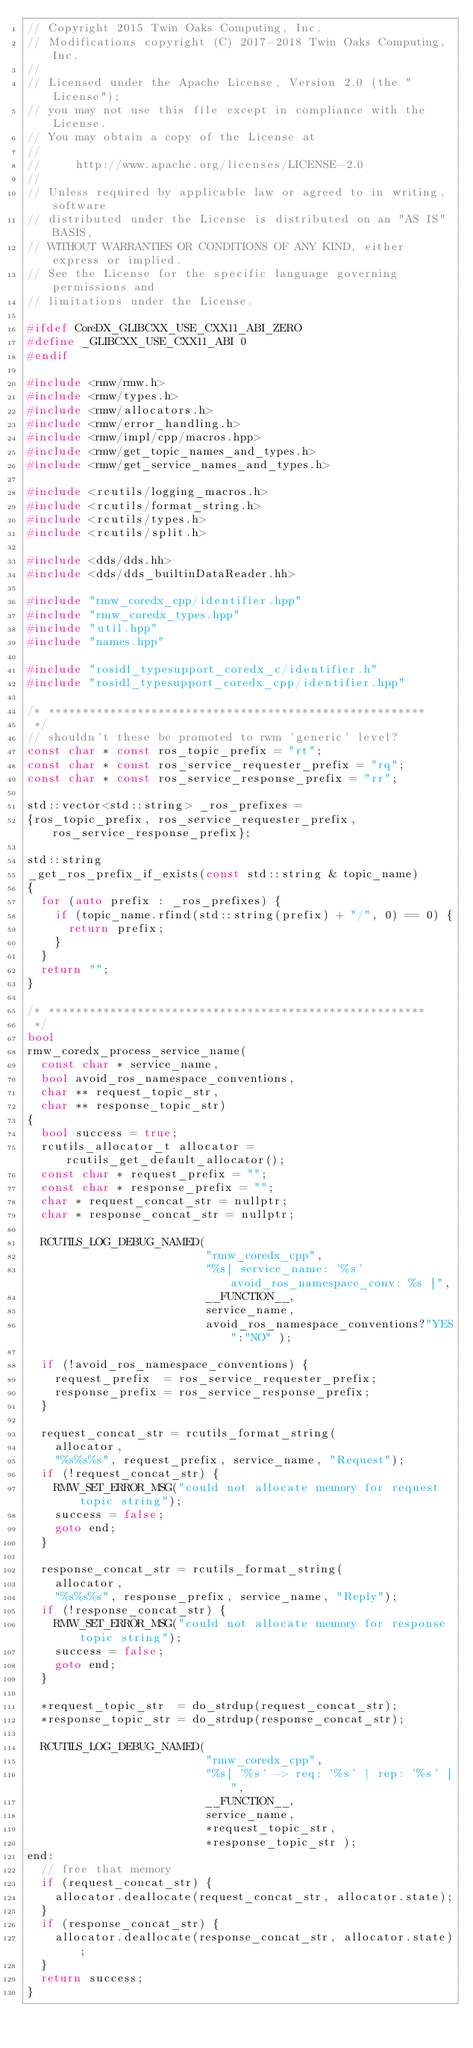<code> <loc_0><loc_0><loc_500><loc_500><_C++_>// Copyright 2015 Twin Oaks Computing, Inc.
// Modifications copyright (C) 2017-2018 Twin Oaks Computing, Inc.
//
// Licensed under the Apache License, Version 2.0 (the "License");
// you may not use this file except in compliance with the License.
// You may obtain a copy of the License at
//
//     http://www.apache.org/licenses/LICENSE-2.0
//
// Unless required by applicable law or agreed to in writing, software
// distributed under the License is distributed on an "AS IS" BASIS,
// WITHOUT WARRANTIES OR CONDITIONS OF ANY KIND, either express or implied.
// See the License for the specific language governing permissions and
// limitations under the License.

#ifdef CoreDX_GLIBCXX_USE_CXX11_ABI_ZERO
#define _GLIBCXX_USE_CXX11_ABI 0
#endif

#include <rmw/rmw.h>
#include <rmw/types.h>
#include <rmw/allocators.h>
#include <rmw/error_handling.h>
#include <rmw/impl/cpp/macros.hpp>
#include <rmw/get_topic_names_and_types.h>
#include <rmw/get_service_names_and_types.h>

#include <rcutils/logging_macros.h>
#include <rcutils/format_string.h>
#include <rcutils/types.h>
#include <rcutils/split.h>

#include <dds/dds.hh>
#include <dds/dds_builtinDataReader.hh>

#include "rmw_coredx_cpp/identifier.hpp"
#include "rmw_coredx_types.hpp"
#include "util.hpp"
#include "names.hpp"

#include "rosidl_typesupport_coredx_c/identifier.h"
#include "rosidl_typesupport_coredx_cpp/identifier.hpp"

/* *******************************************************
 */
// shouldn't these be promoted to rwm 'generic' level?
const char * const ros_topic_prefix = "rt";
const char * const ros_service_requester_prefix = "rq";
const char * const ros_service_response_prefix = "rr";

std::vector<std::string> _ros_prefixes =
{ros_topic_prefix, ros_service_requester_prefix, ros_service_response_prefix};

std::string
_get_ros_prefix_if_exists(const std::string & topic_name)
{
  for (auto prefix : _ros_prefixes) {
    if (topic_name.rfind(std::string(prefix) + "/", 0) == 0) {
      return prefix;
    }
  }
  return "";
}

/* *******************************************************
 */
bool
rmw_coredx_process_service_name(
  const char * service_name,
  bool avoid_ros_namespace_conventions,
  char ** request_topic_str,
  char ** response_topic_str)
{
  bool success = true;
  rcutils_allocator_t allocator = rcutils_get_default_allocator();
  const char * request_prefix = "";
  const char * response_prefix = "";
  char * request_concat_str = nullptr;
  char * response_concat_str = nullptr;

  RCUTILS_LOG_DEBUG_NAMED(
                          "rmw_coredx_cpp",
                          "%s[ service_name: '%s' avoid_ros_namespace_conv: %s ]",
                          __FUNCTION__,
                          service_name,
                          avoid_ros_namespace_conventions?"YES":"NO" );
  
  if (!avoid_ros_namespace_conventions) {
    request_prefix  = ros_service_requester_prefix;
    response_prefix = ros_service_response_prefix;
  }
  
  request_concat_str = rcutils_format_string(
    allocator,
    "%s%s%s", request_prefix, service_name, "Request");
  if (!request_concat_str) {
    RMW_SET_ERROR_MSG("could not allocate memory for request topic string");
    success = false;
    goto end;
  }
  
  response_concat_str = rcutils_format_string(
    allocator,
    "%s%s%s", response_prefix, service_name, "Reply");
  if (!response_concat_str) {
    RMW_SET_ERROR_MSG("could not allocate memory for response topic string");
    success = false;
    goto end;
  }
  
  *request_topic_str  = do_strdup(request_concat_str);
  *response_topic_str = do_strdup(response_concat_str);

  RCUTILS_LOG_DEBUG_NAMED(
                          "rmw_coredx_cpp",
                          "%s[ '%s' -> req: '%s' | rep: '%s' ]",
                          __FUNCTION__,
                          service_name, 
                          *request_topic_str,
                          *response_topic_str );
end:
  // free that memory
  if (request_concat_str) {
    allocator.deallocate(request_concat_str, allocator.state);
  }
  if (response_concat_str) {
    allocator.deallocate(response_concat_str, allocator.state);
  }
  return success;
}
</code> 